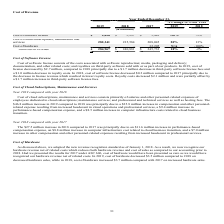According to Manhattan Associates's financial document, What is the total cost of revenue in 2019? According to the financial document, $ 284,967 (in thousands). The relevant text states: "Total cost of revenue $ 284,967 $ 240,881 $ 245,733 18% -2%..." Also, What caused the cost of software license to go down in 2019? a $1.7 million decrease in third-party software license fees and a $1.0 million decrease in royalty costs.. The document states: "$2.7 million, compared to 2018 principally due to a $1.7 million decrease in third-party software license fees and a $1.0 million decrease in royalty ..." Also, Why did cost of hardware goes to zero in 2019 and 2018?  Adopted the new revenue recognition standard as of January 1, 2018. The document states: "As discussed above, we adopted the new revenue recognition standard as of January 1, 2018. As a result, we now recognize our hardware revenue net of r..." Also, can you calculate: What is the difference between cost of software license and cost of cloud subscriptions, maintenance and services in 2019? Based on the calculation: $282,341-$2,626, the result is 279715 (in thousands). This is based on the information: "282,341 Cost of software license $ 2,626 $ 5,297 $ 5,483 -50% -3%..." The key data points involved are: 2,626, 282,341. Additionally, Which years had the highest total cost of revenue? According to the financial document, 2019. The relevant text states: "2019 2018 2017 2019 2018..." Also, can you calculate: What is the change in the total cost of revenue between 2018 and 2019? Based on the calculation: 284,967-240,881, the result is 44086 (in thousands). This is based on the information: "Total cost of revenue $ 284,967 $ 240,881 $ 245,733 18% -2% Total cost of revenue $ 284,967 $ 240,881 $ 245,733 18% -2%..." The key data points involved are: 240,881, 284,967. 